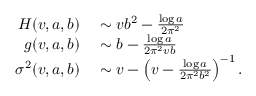Convert formula to latex. <formula><loc_0><loc_0><loc_500><loc_500>\begin{array} { r l } { H ( v , a , b ) } & \sim v b ^ { 2 } - \frac { \log a } { 2 \pi ^ { 2 } } } \\ { g ( v , a , b ) } & \sim b - \frac { \log a } { 2 \pi ^ { 2 } v b } } \\ { \sigma ^ { 2 } ( v , a , b ) } & \sim v - \left ( v - \frac { \log a } { 2 \pi ^ { 2 } b ^ { 2 } } \right ) ^ { - 1 } . } \end{array}</formula> 